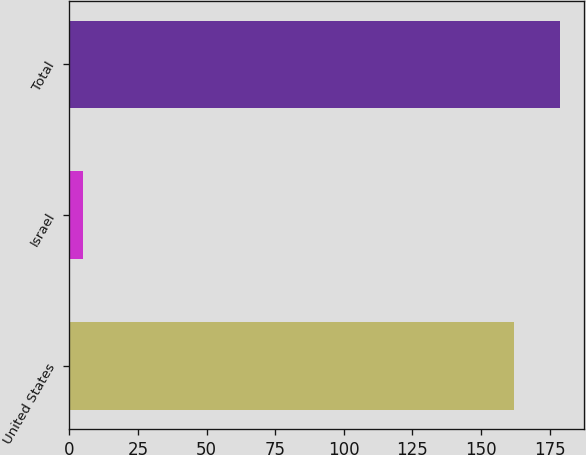<chart> <loc_0><loc_0><loc_500><loc_500><bar_chart><fcel>United States<fcel>Israel<fcel>Total<nl><fcel>162<fcel>5<fcel>178.6<nl></chart> 